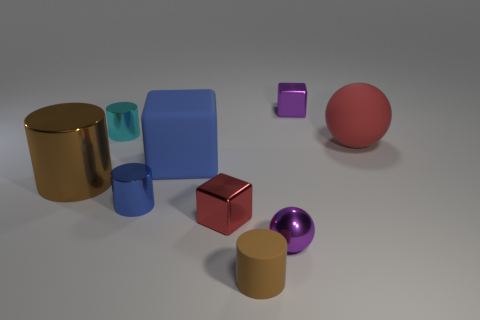There is a metallic thing that is the same color as the large block; what size is it?
Provide a short and direct response. Small. Is the shape of the purple shiny thing in front of the big metal object the same as  the large blue object?
Make the answer very short. No. What number of other things are the same shape as the large brown thing?
Offer a very short reply. 3. There is a purple shiny thing that is in front of the large matte sphere; what shape is it?
Offer a very short reply. Sphere. Are there any purple objects that have the same material as the large sphere?
Give a very brief answer. No. There is a metallic cube in front of the large red rubber ball; is its color the same as the big block?
Offer a terse response. No. How big is the red shiny block?
Your response must be concise. Small. There is a shiny block in front of the large rubber thing that is behind the matte block; is there a red block left of it?
Your answer should be very brief. No. There is a cyan object; how many large rubber balls are behind it?
Offer a very short reply. 0. How many rubber objects have the same color as the large rubber cube?
Make the answer very short. 0. 